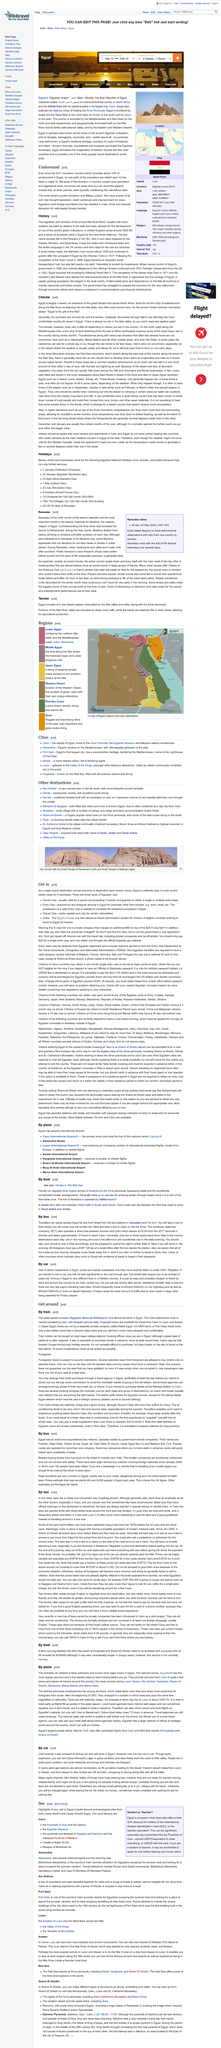Identify some key points in this picture. It is required that individuals in Egypt be at least 21 years old in order to rent a car. Gas in Egypt is currently sold at a price of under $1.50 USD per gallon, making it one of the most affordable options for drivers in the country. Friday has the least traffic on the roads in Egypt. 